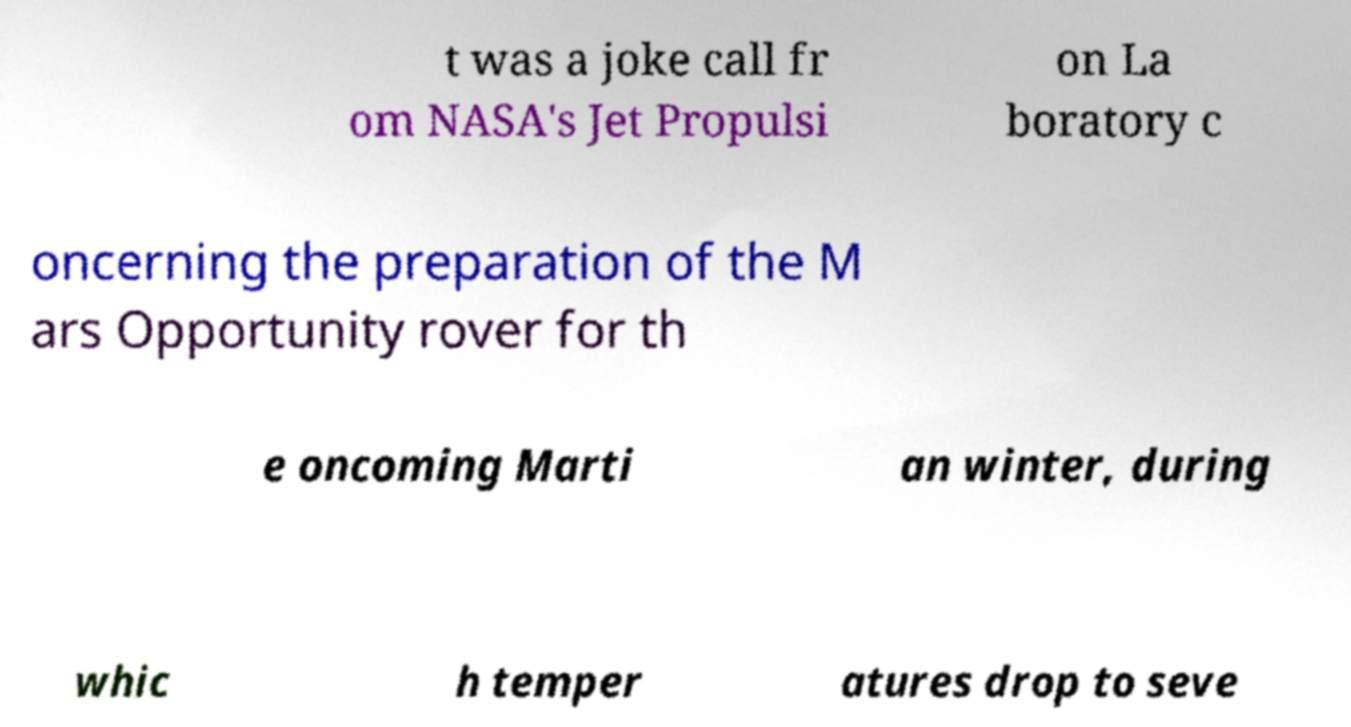Could you assist in decoding the text presented in this image and type it out clearly? t was a joke call fr om NASA's Jet Propulsi on La boratory c oncerning the preparation of the M ars Opportunity rover for th e oncoming Marti an winter, during whic h temper atures drop to seve 